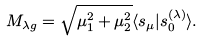Convert formula to latex. <formula><loc_0><loc_0><loc_500><loc_500>M _ { \lambda g } = \sqrt { \mu _ { 1 } ^ { 2 } + \mu _ { 2 } ^ { 2 } } \langle s _ { \mu } | s _ { 0 } ^ { ( \lambda ) } \rangle .</formula> 